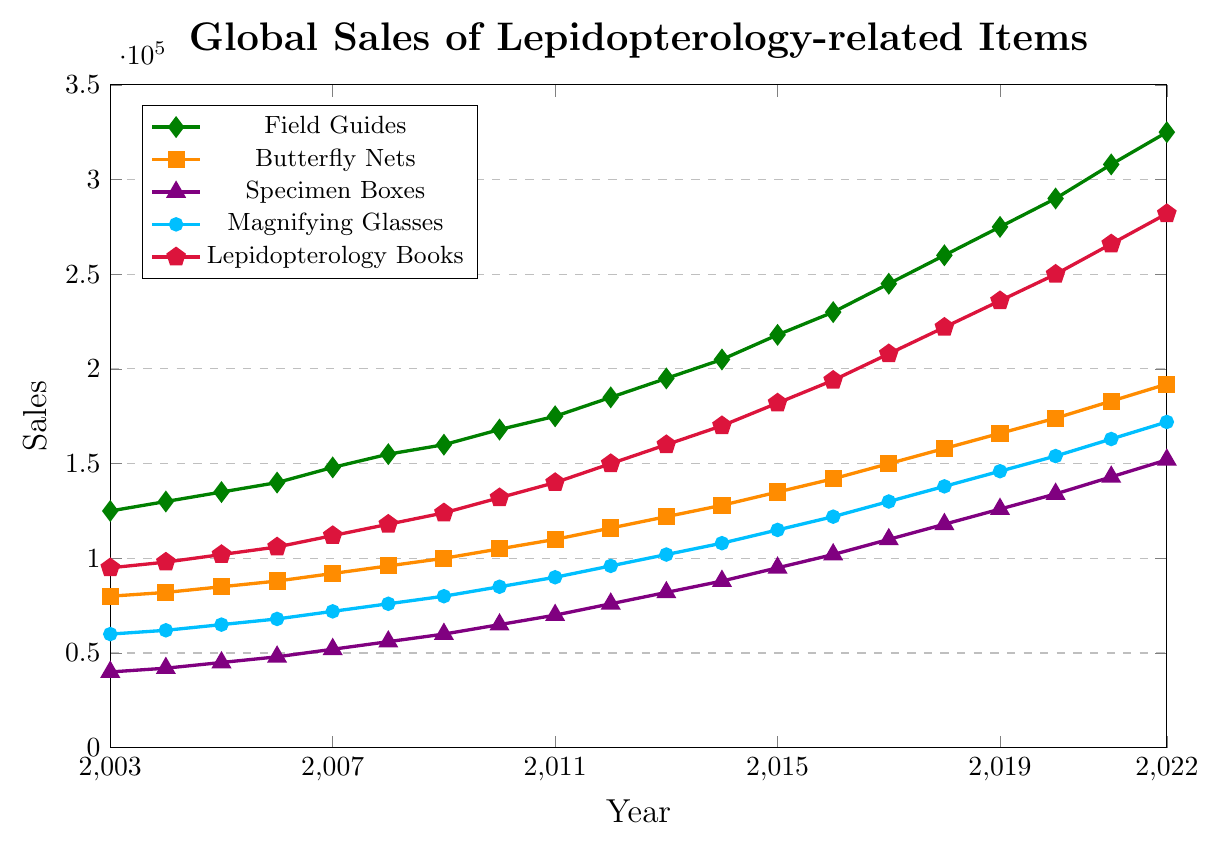Which item had the highest sales in 2022? The figure shows sales of five lepidopterology-related items from 2003 to 2022. Examine the endpoint for each line in 2022 to find the highest value. Lepidopterology Books, marked in red, had the highest sales in 2022.
Answer: Lepidopterology Books Compare the sales of Butterfly Nets and Specimen Boxes in 2015. Which had higher sales? Look for the sales values of Butterfly Nets and Specimen Boxes in 2015 on the figure. Butterfly Nets had higher sales as its line is higher than that of Specimen Boxes.
Answer: Butterfly Nets What is the average sales for Magnifying Glasses from 2010 to 2015, inclusive? To find the average, sum the values from 2010 to 2015 and then divide by the number of years. (85000 + 90000 + 96000 + 102000 + 108000 + 115000) / 6 = 596000 / 6
Answer: 99333.33 In which year did Field Guides sales first exceed 200,000? Trace the Field Guides sales line up to the year 2014, where it first crosses the 200,000 mark.
Answer: 2014 By how much did the sales of Lepidopterology Books increase from 2006 to 2022? Subtract the sales in 2006 from the sales in 2022. 282000 (2022) - 106000 (2006) = 176000.
Answer: 176000 Which item had the most significant growth in sales from 2003 to 2022? Assess the starting and ending points for all items from 2003 to 2022. Lepidopterology Books (red line) had the steepest increase.
Answer: Lepidopterology Books What was the difference in sales between Field Guides and Magnifying Glasses in 2020? Subtract the sales of Magnifying Glasses from the sales of Field Guides in 2020. 290000 (Field Guides) - 154000 (Magnifying Glasses) = 136000.
Answer: 136000 Which year did Specimen Boxes sales reach 100,000? Look for the year when the Specimen Boxes line (purple) crosses the 100,000 mark, which occurs in 2016.
Answer: 2016 Between 2011 and 2014, which item had the steepest growth in sales? Compare the slopes of lines for each item between 2011 and 2014. Lepidopterology Books (red) shows the most significant growth.
Answer: Lepidopterology Books 